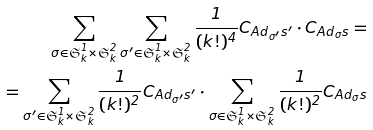<formula> <loc_0><loc_0><loc_500><loc_500>\sum _ { \sigma \in \mathfrak { S } ^ { 1 } _ { k } \times \mathfrak { S } ^ { 2 } _ { k } } \sum _ { \sigma ^ { \prime } \in \mathfrak { S } ^ { 1 } _ { k } \times \mathfrak { S } ^ { 2 } _ { k } } \frac { 1 } { ( k ! ) ^ { 4 } } C _ { A d _ { \sigma ^ { \prime } } s ^ { \prime } } \cdot C _ { A d _ { \sigma } s } = \\ = \sum _ { \sigma ^ { \prime } \in \mathfrak { S } ^ { 1 } _ { k } \times \mathfrak { S } ^ { 2 } _ { k } } \frac { 1 } { ( k ! ) ^ { 2 } } C _ { A d _ { \sigma ^ { \prime } } s ^ { \prime } } \cdot \sum _ { \sigma \in \mathfrak { S } ^ { 1 } _ { k } \times \mathfrak { S } ^ { 2 } _ { k } } \frac { 1 } { ( k ! ) ^ { 2 } } C _ { A d _ { \sigma } s }</formula> 